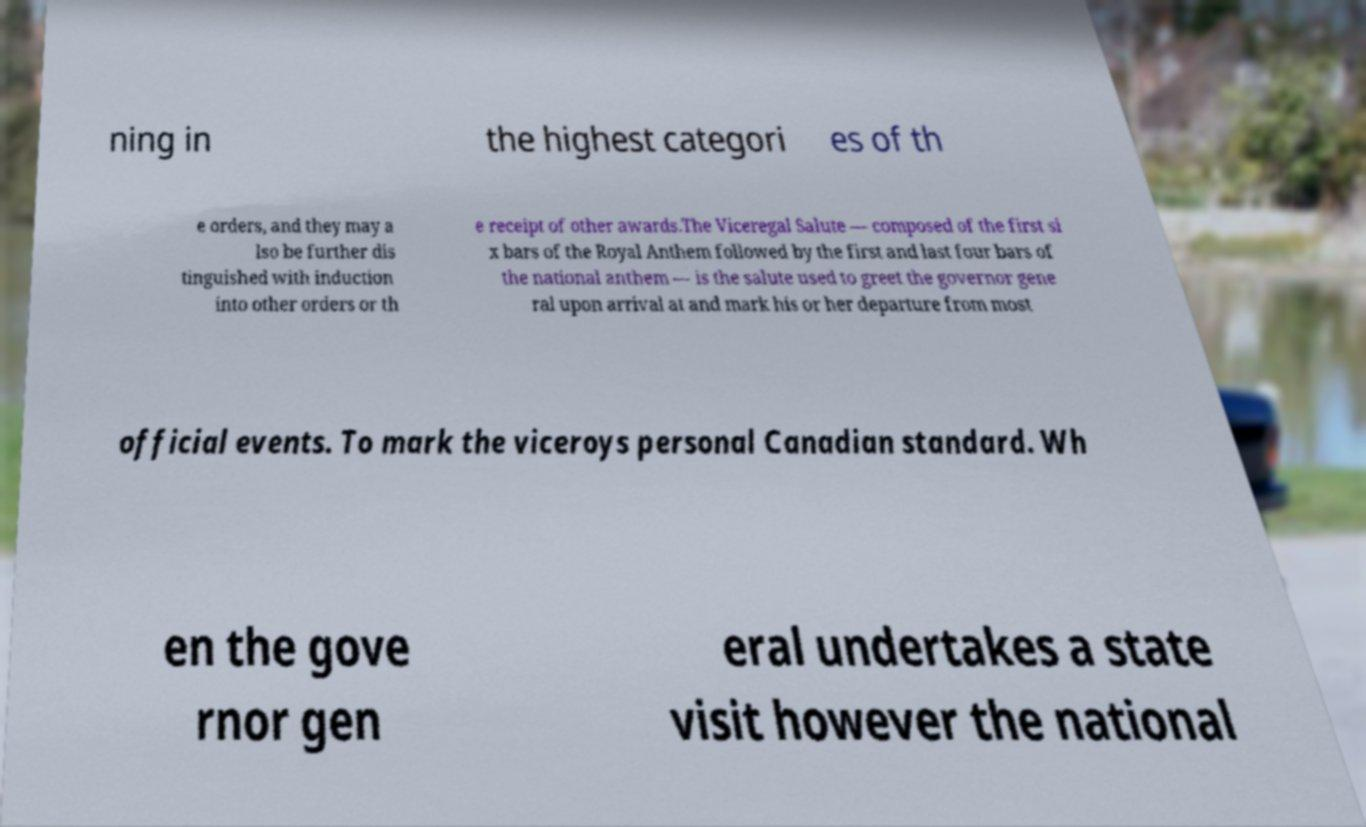I need the written content from this picture converted into text. Can you do that? ning in the highest categori es of th e orders, and they may a lso be further dis tinguished with induction into other orders or th e receipt of other awards.The Viceregal Salute — composed of the first si x bars of the Royal Anthem followed by the first and last four bars of the national anthem — is the salute used to greet the governor gene ral upon arrival at and mark his or her departure from most official events. To mark the viceroys personal Canadian standard. Wh en the gove rnor gen eral undertakes a state visit however the national 